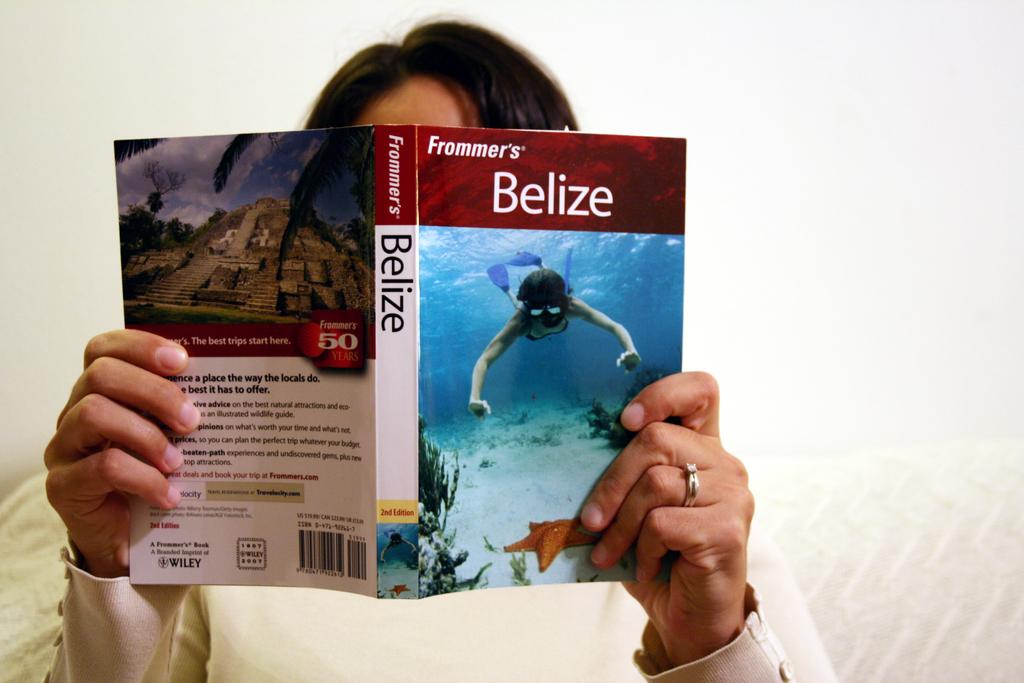<image>
Provide a brief description of the given image. a book that has the name Belize written on it 